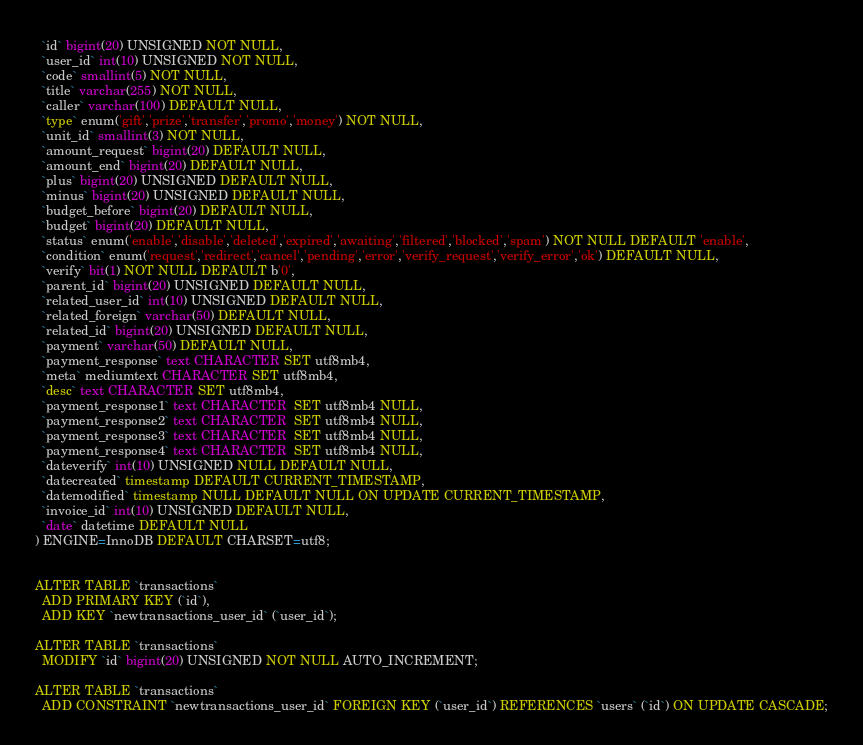<code> <loc_0><loc_0><loc_500><loc_500><_SQL_>  `id` bigint(20) UNSIGNED NOT NULL,
  `user_id` int(10) UNSIGNED NOT NULL,
  `code` smallint(5) NOT NULL,
  `title` varchar(255) NOT NULL,
  `caller` varchar(100) DEFAULT NULL,
  `type` enum('gift','prize','transfer','promo','money') NOT NULL,
  `unit_id` smallint(3) NOT NULL,
  `amount_request` bigint(20) DEFAULT NULL,
  `amount_end` bigint(20) DEFAULT NULL,
  `plus` bigint(20) UNSIGNED DEFAULT NULL,
  `minus` bigint(20) UNSIGNED DEFAULT NULL,
  `budget_before` bigint(20) DEFAULT NULL,
  `budget` bigint(20) DEFAULT NULL,
  `status` enum('enable','disable','deleted','expired','awaiting','filtered','blocked','spam') NOT NULL DEFAULT 'enable',
  `condition` enum('request','redirect','cancel','pending','error','verify_request','verify_error','ok') DEFAULT NULL,
  `verify` bit(1) NOT NULL DEFAULT b'0',
  `parent_id` bigint(20) UNSIGNED DEFAULT NULL,
  `related_user_id` int(10) UNSIGNED DEFAULT NULL,
  `related_foreign` varchar(50) DEFAULT NULL,
  `related_id` bigint(20) UNSIGNED DEFAULT NULL,
  `payment` varchar(50) DEFAULT NULL,
  `payment_response` text CHARACTER SET utf8mb4,
  `meta` mediumtext CHARACTER SET utf8mb4,
  `desc` text CHARACTER SET utf8mb4,
  `payment_response1` text CHARACTER  SET utf8mb4 NULL,
  `payment_response2` text CHARACTER  SET utf8mb4 NULL,
  `payment_response3` text CHARACTER  SET utf8mb4 NULL,
  `payment_response4` text CHARACTER  SET utf8mb4 NULL,
  `dateverify` int(10) UNSIGNED NULL DEFAULT NULL,
  `datecreated` timestamp DEFAULT CURRENT_TIMESTAMP,
  `datemodified` timestamp NULL DEFAULT NULL ON UPDATE CURRENT_TIMESTAMP,
  `invoice_id` int(10) UNSIGNED DEFAULT NULL,
  `date` datetime DEFAULT NULL
) ENGINE=InnoDB DEFAULT CHARSET=utf8;


ALTER TABLE `transactions`
  ADD PRIMARY KEY (`id`),
  ADD KEY `newtransactions_user_id` (`user_id`);

ALTER TABLE `transactions`
  MODIFY `id` bigint(20) UNSIGNED NOT NULL AUTO_INCREMENT;

ALTER TABLE `transactions`
  ADD CONSTRAINT `newtransactions_user_id` FOREIGN KEY (`user_id`) REFERENCES `users` (`id`) ON UPDATE CASCADE;
</code> 